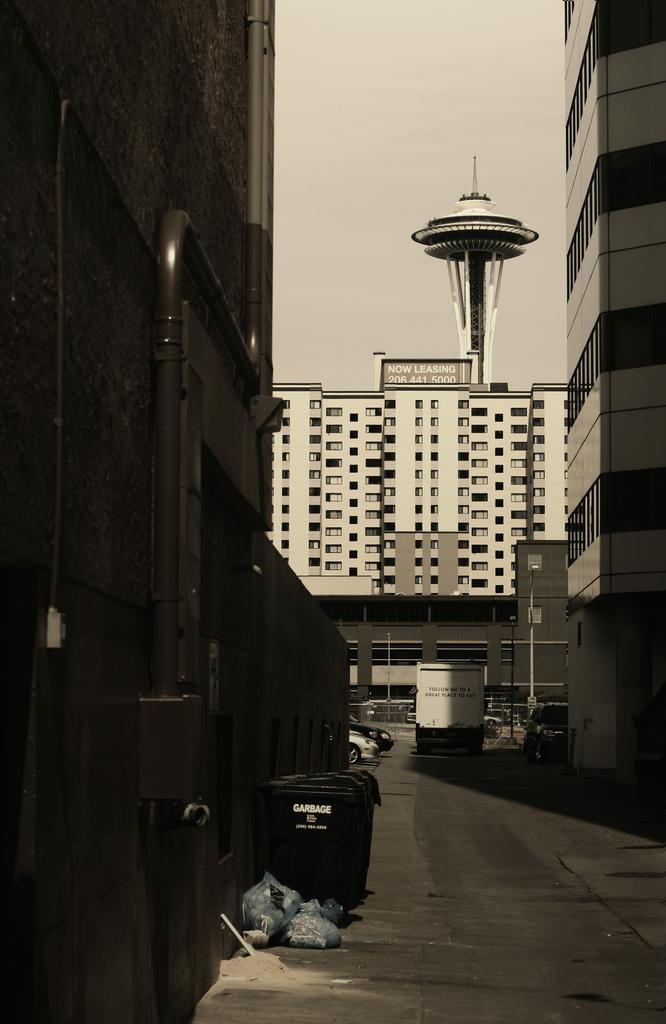What object can be seen in the image for disposing of waste? There is a dustbin in the image. What is covering the path in the image? There are covers on the path in the image. What type of transportation can be seen on the road in the image? There are vehicles on the road in the image. What can be seen in the background of the image? There are buildings and a tower in the background of the image. Can you see a frog hopping on the dustbin in the image? There is no frog present in the image. What type of connection is visible between the vehicles on the road in the image? The image does not show any specific connections between the vehicles; it only shows them on the road. 